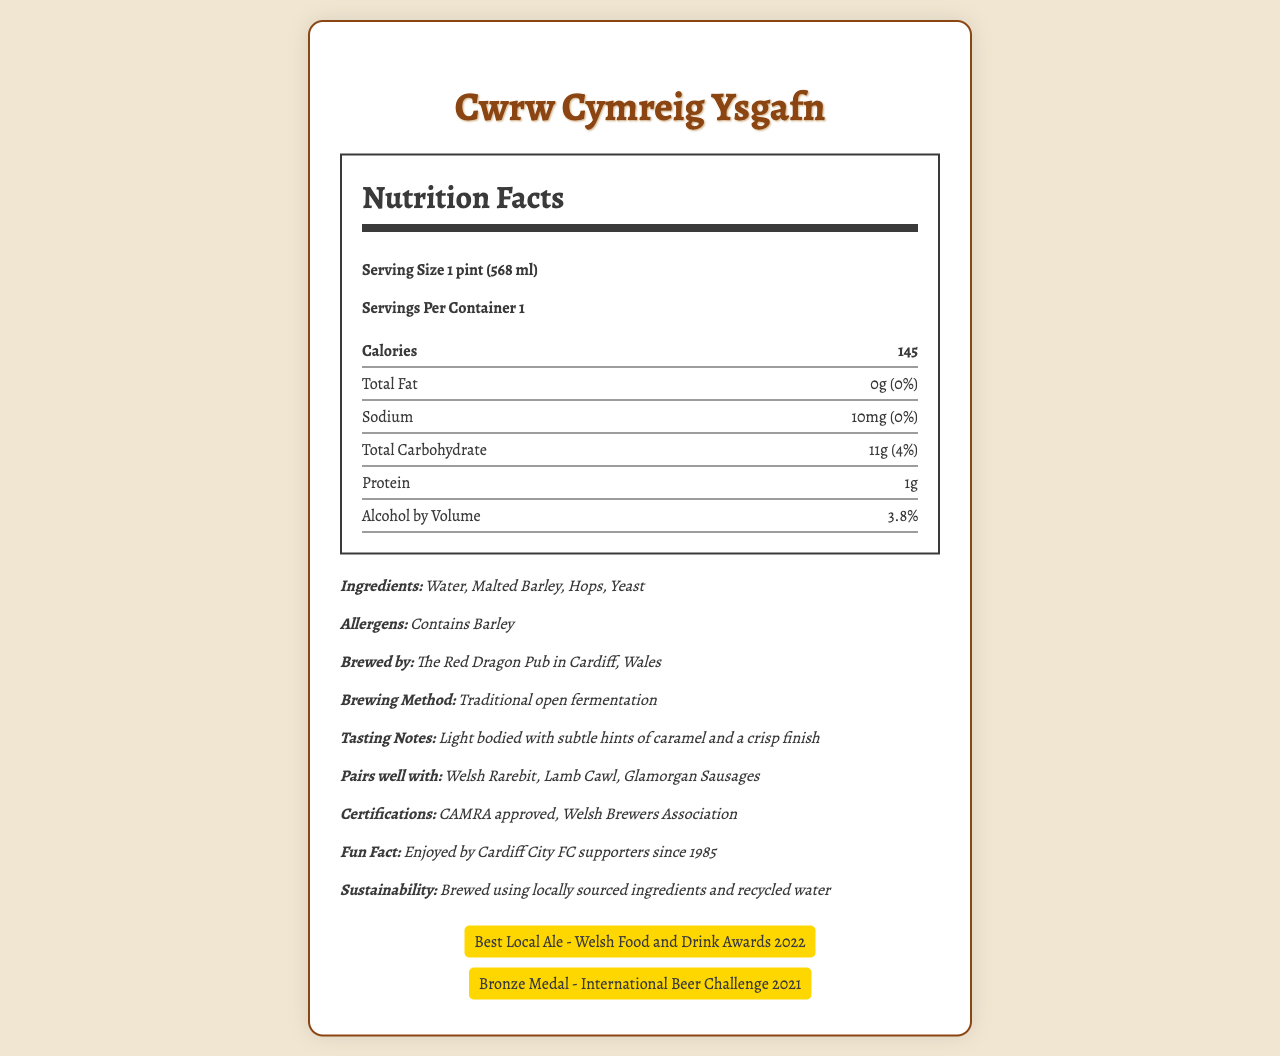what is the serving size? The serving size is explicitly mentioned as "1 pint (568 ml)" in the document.
Answer: 1 pint (568 ml) how many calories are in one serving of Cwrw Cymreig Ysgafn? The document states that one serving contains 145 calories.
Answer: 145 calories what is the total fat content in Cwrw Cymreig Ysgafn? The total fat content is listed as "0g" in the nutrition facts section of the document.
Answer: 0g what is the alcohol by volume (ABV) of this ale? The alcohol by volume is specified as 3.8% in the document.
Answer: 3.8% what are the main ingredients of Cwrw Cymreig Ysgafn? The main ingredients listed in the document are Water, Malted Barley, Hops, and Yeast.
Answer: Water, Malted Barley, Hops, Yeast which of the following dishes pairs well with Cwrw Cymreig Ysgafn? A. Fish and Chips B. Welsh Rarebit C. Spaghetti Carbonara D. Cheese Pizza According to the document, Welsh Rarebit is one of the dishes that pairs well with Cwrw Cymreig Ysgafn.
Answer: B. Welsh Rarebit what are the certifications mentioned for Cwrw Cymreig Ysgafn? A. USDA Organic B. Fair Trade Certified C. CAMRA approved D. Welsh Brewers Association E. Gluten-Free The document lists "CAMRA approved" and "Welsh Brewers Association" as the certifications for Cwrw Cymreig Ysgafn.
Answer: C. CAMRA approved and D. Welsh Brewers Association is the beer gluten-free? The document lists "Contains Barley" under allergens, indicating it is not gluten-free.
Answer: No summarize the main points of this document. The document highlights the nutritional content, ingredients, brewing method, tasting notes, pairings, certifications, sustainability practices, and awards of the ale.
Answer: The document provides the nutrition facts and detailed information about "Cwrw Cymreig Ysgafn", a traditional Welsh ale brewed on-site at The Red Dragon Pub in Cardiff, Wales. It has 145 calories per pint, low fat and sodium content, and an ABV of 3.8%. Key ingredients are water, malted barley, hops, and yeast. It pairs well with Welsh dishes and has received CAMRA and Welsh Brewers Association certifications. The ale is brewed using traditional methods and sustainable practices. what year did Cardiff City FC supporters start enjoying Cwrw Cymreig Ysgafn? The document includes a fun fact that mentions Cardiff City FC supporters have been enjoying the ale since 1985.
Answer: 1985 what method is used to brew Cwrw Cymreig Ysgafn? Under the extra information section, the brewing method is stated as "Traditional open fermentation".
Answer: Traditional open fermentation how many awards has Cwrw Cymreig Ysgafn won? The document mentions two awards: "Best Local Ale - Welsh Food and Drink Awards 2022" and "Bronze Medal - International Beer Challenge 2021".
Answer: Two awards what is the sodium content of the ale? The nutrition facts section lists the sodium content as 10mg.
Answer: 10mg does this ale contain any allergens? The document indicates that the ale contains barley as an allergen.
Answer: Yes Is this ale high in protein? The document states the protein content is 1g, which is not considered high.
Answer: No did Cwrw Cymreig Ysgafn win the best international ale award? The document only mentions "Best Local Ale" and "Bronze Medal" awards but does not specify all potential awards it may have won.
Answer: Cannot be determined 